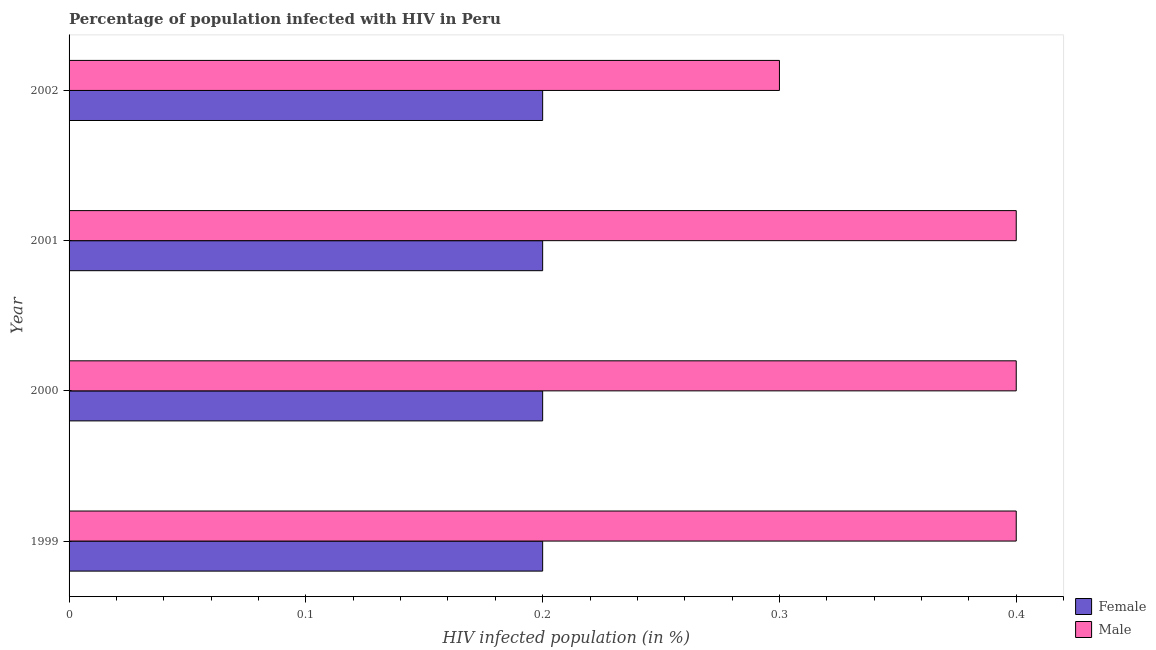Are the number of bars per tick equal to the number of legend labels?
Make the answer very short. Yes. How many bars are there on the 3rd tick from the bottom?
Keep it short and to the point. 2. What is the label of the 1st group of bars from the top?
Provide a succinct answer. 2002. What is the percentage of females who are infected with hiv in 2002?
Your response must be concise. 0.2. In which year was the percentage of females who are infected with hiv maximum?
Keep it short and to the point. 1999. In which year was the percentage of females who are infected with hiv minimum?
Give a very brief answer. 1999. What is the difference between the percentage of females who are infected with hiv in 1999 and that in 2002?
Offer a very short reply. 0. What is the difference between the percentage of males who are infected with hiv in 1999 and the percentage of females who are infected with hiv in 2001?
Keep it short and to the point. 0.2. In the year 1999, what is the difference between the percentage of males who are infected with hiv and percentage of females who are infected with hiv?
Make the answer very short. 0.2. In how many years, is the percentage of males who are infected with hiv greater than 0.30000000000000004 %?
Your answer should be compact. 3. In how many years, is the percentage of males who are infected with hiv greater than the average percentage of males who are infected with hiv taken over all years?
Your answer should be very brief. 3. Is the sum of the percentage of males who are infected with hiv in 1999 and 2002 greater than the maximum percentage of females who are infected with hiv across all years?
Provide a short and direct response. Yes. What does the 1st bar from the top in 1999 represents?
Make the answer very short. Male. What does the 2nd bar from the bottom in 2002 represents?
Ensure brevity in your answer.  Male. Are all the bars in the graph horizontal?
Offer a terse response. Yes. Does the graph contain any zero values?
Provide a short and direct response. No. Does the graph contain grids?
Your response must be concise. No. How are the legend labels stacked?
Make the answer very short. Vertical. What is the title of the graph?
Provide a succinct answer. Percentage of population infected with HIV in Peru. What is the label or title of the X-axis?
Your answer should be compact. HIV infected population (in %). What is the label or title of the Y-axis?
Your answer should be very brief. Year. What is the HIV infected population (in %) of Male in 1999?
Ensure brevity in your answer.  0.4. What is the HIV infected population (in %) in Female in 2001?
Give a very brief answer. 0.2. What is the HIV infected population (in %) in Male in 2002?
Provide a short and direct response. 0.3. Across all years, what is the maximum HIV infected population (in %) in Female?
Provide a short and direct response. 0.2. Across all years, what is the maximum HIV infected population (in %) in Male?
Make the answer very short. 0.4. What is the total HIV infected population (in %) in Male in the graph?
Provide a succinct answer. 1.5. What is the difference between the HIV infected population (in %) of Female in 1999 and that in 2000?
Keep it short and to the point. 0. What is the difference between the HIV infected population (in %) of Female in 1999 and that in 2001?
Your answer should be compact. 0. What is the difference between the HIV infected population (in %) of Male in 1999 and that in 2001?
Your answer should be compact. 0. What is the difference between the HIV infected population (in %) in Female in 1999 and that in 2002?
Offer a terse response. 0. What is the difference between the HIV infected population (in %) in Female in 2000 and that in 2001?
Offer a terse response. 0. What is the difference between the HIV infected population (in %) in Female in 2000 and that in 2002?
Provide a succinct answer. 0. What is the difference between the HIV infected population (in %) in Female in 1999 and the HIV infected population (in %) in Male in 2000?
Your response must be concise. -0.2. What is the difference between the HIV infected population (in %) in Female in 1999 and the HIV infected population (in %) in Male in 2001?
Provide a succinct answer. -0.2. What is the difference between the HIV infected population (in %) in Female in 2000 and the HIV infected population (in %) in Male in 2001?
Make the answer very short. -0.2. What is the difference between the HIV infected population (in %) of Female in 2000 and the HIV infected population (in %) of Male in 2002?
Give a very brief answer. -0.1. What is the average HIV infected population (in %) in Male per year?
Provide a succinct answer. 0.38. In the year 1999, what is the difference between the HIV infected population (in %) in Female and HIV infected population (in %) in Male?
Make the answer very short. -0.2. In the year 2000, what is the difference between the HIV infected population (in %) of Female and HIV infected population (in %) of Male?
Make the answer very short. -0.2. What is the ratio of the HIV infected population (in %) in Female in 1999 to that in 2000?
Offer a very short reply. 1. What is the ratio of the HIV infected population (in %) of Male in 1999 to that in 2000?
Offer a very short reply. 1. What is the ratio of the HIV infected population (in %) of Female in 1999 to that in 2001?
Give a very brief answer. 1. What is the ratio of the HIV infected population (in %) of Female in 1999 to that in 2002?
Keep it short and to the point. 1. What is the ratio of the HIV infected population (in %) in Male in 1999 to that in 2002?
Keep it short and to the point. 1.33. What is the ratio of the HIV infected population (in %) in Male in 2000 to that in 2001?
Provide a succinct answer. 1. What is the ratio of the HIV infected population (in %) in Female in 2001 to that in 2002?
Make the answer very short. 1. 